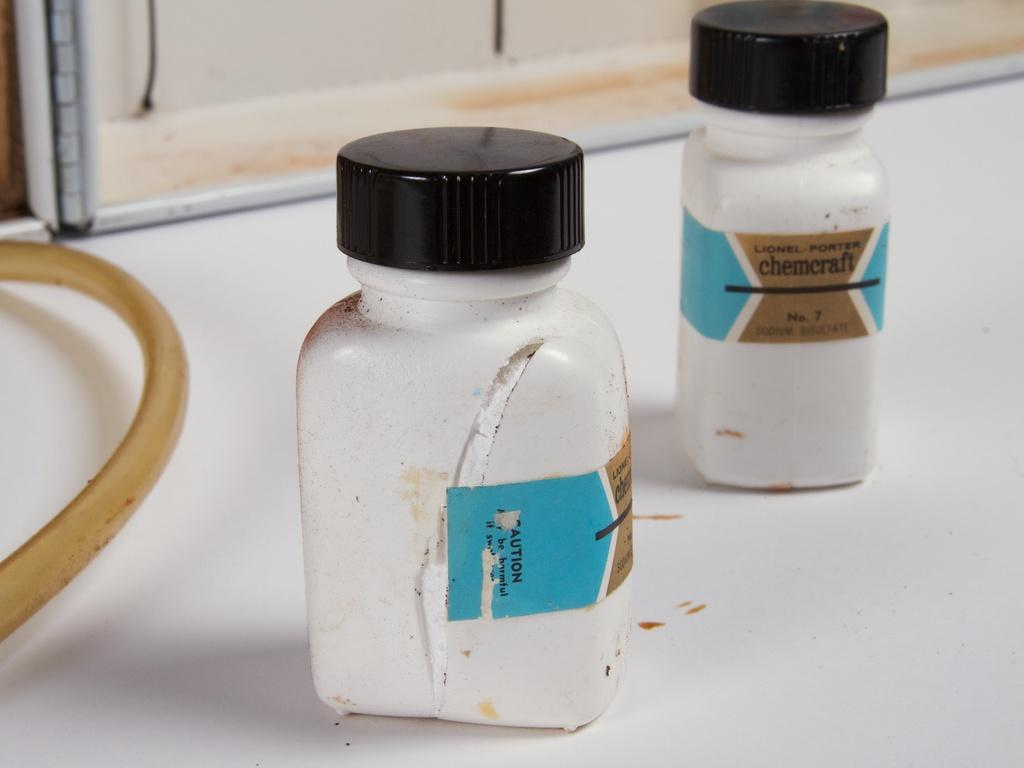<image>
Provide a brief description of the given image. Two small white bottles of Chemcraft sit on a white counter. 